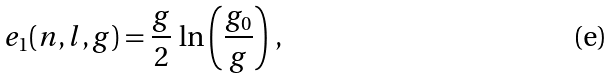Convert formula to latex. <formula><loc_0><loc_0><loc_500><loc_500>e _ { 1 } ( n , l , g ) = \frac { g } { 2 } \, \ln \left ( \frac { g _ { 0 } } { g } \right ) \, ,</formula> 